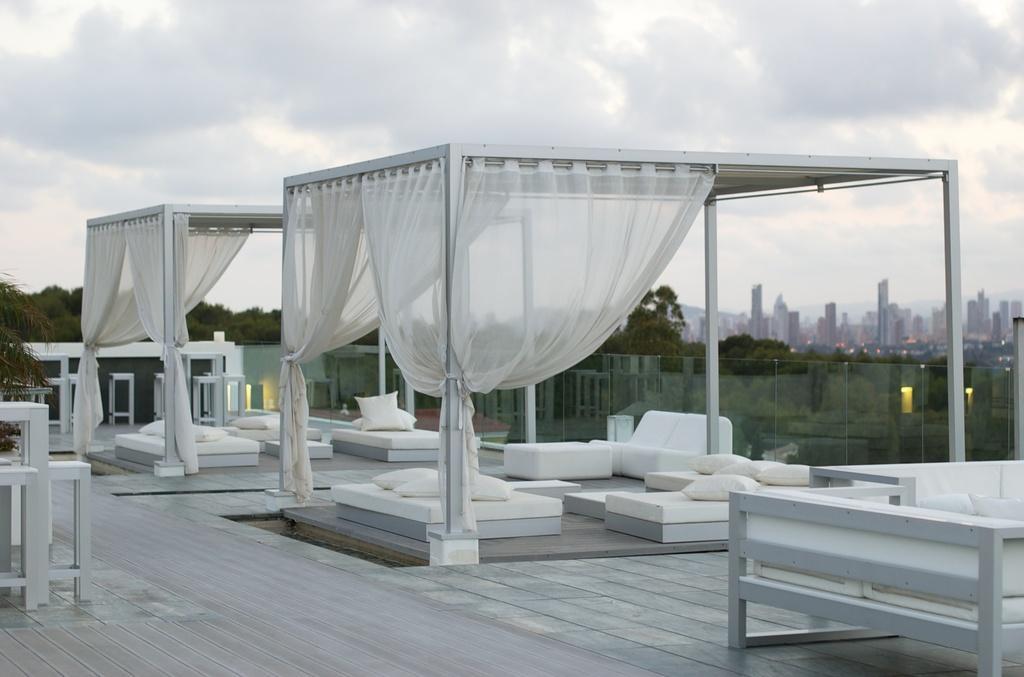Could you give a brief overview of what you see in this image? In this picture we can see this place is on the top of the building. Here we can see white sofa, white bed, white pillows. White curtains are hanging to the pole. And to the boundaries of that building there are white glasses fixed to it. In the background we can see many buildings, trees and a cloudy sky. 